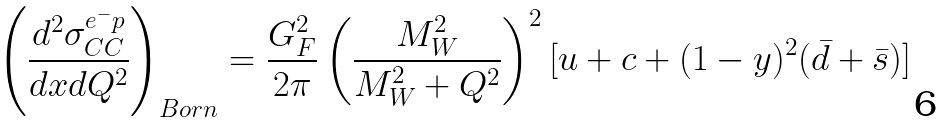Convert formula to latex. <formula><loc_0><loc_0><loc_500><loc_500>\left ( \frac { d ^ { 2 } \sigma _ { C C } ^ { e ^ { - } p } } { d x d Q ^ { 2 } } \right ) _ { B o r n } = \frac { G _ { F } ^ { 2 } } { 2 \pi } \left ( \frac { M _ { W } ^ { 2 } } { M _ { W } ^ { 2 } + Q ^ { 2 } } \right ) ^ { 2 } [ u + c + ( 1 - y ) ^ { 2 } ( \bar { d } + \bar { s } ) ]</formula> 